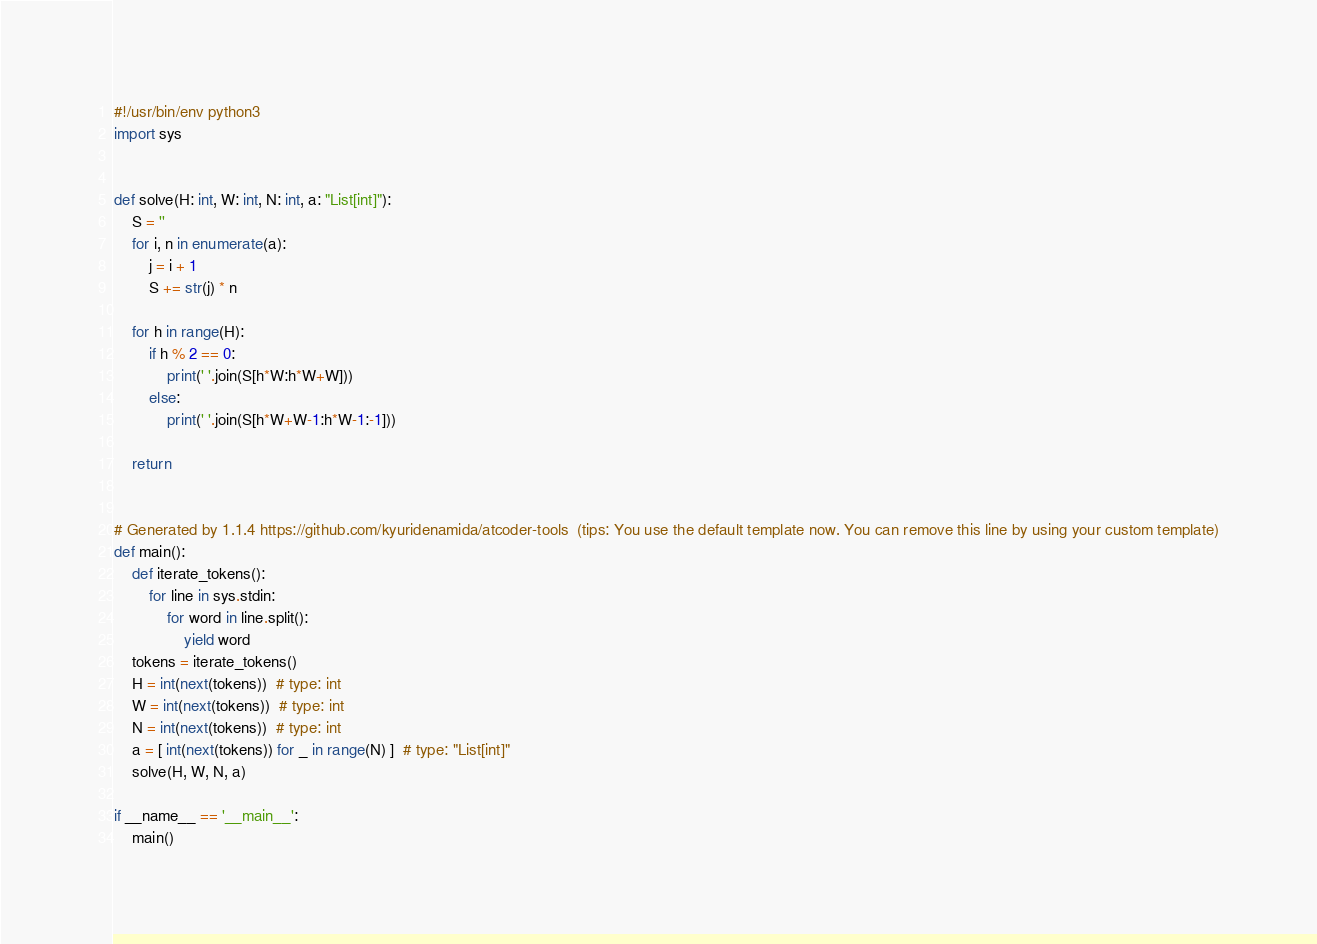<code> <loc_0><loc_0><loc_500><loc_500><_Python_>#!/usr/bin/env python3
import sys


def solve(H: int, W: int, N: int, a: "List[int]"):
    S = ''
    for i, n in enumerate(a):
        j = i + 1
        S += str(j) * n
    
    for h in range(H):
        if h % 2 == 0:
            print(' '.join(S[h*W:h*W+W]))
        else:
            print(' '.join(S[h*W+W-1:h*W-1:-1]))

    return


# Generated by 1.1.4 https://github.com/kyuridenamida/atcoder-tools  (tips: You use the default template now. You can remove this line by using your custom template)
def main():
    def iterate_tokens():
        for line in sys.stdin:
            for word in line.split():
                yield word
    tokens = iterate_tokens()
    H = int(next(tokens))  # type: int
    W = int(next(tokens))  # type: int
    N = int(next(tokens))  # type: int
    a = [ int(next(tokens)) for _ in range(N) ]  # type: "List[int]"
    solve(H, W, N, a)

if __name__ == '__main__':
    main()
</code> 